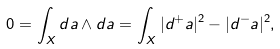<formula> <loc_0><loc_0><loc_500><loc_500>0 = \int _ { X } d a \wedge d a = \int _ { X } | d ^ { + } a | ^ { 2 } - | d ^ { - } a | ^ { 2 } ,</formula> 